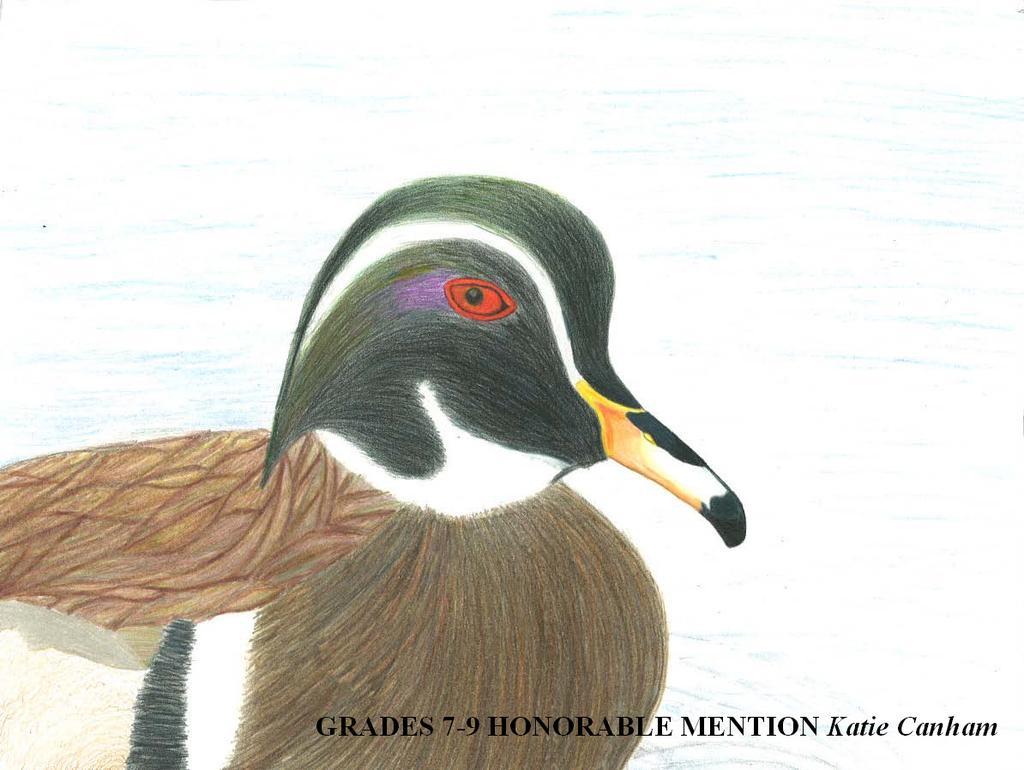How would you summarize this image in a sentence or two? It is a painting and it looks like a duck in black and other colors. At the bottom there is the name in black color. 